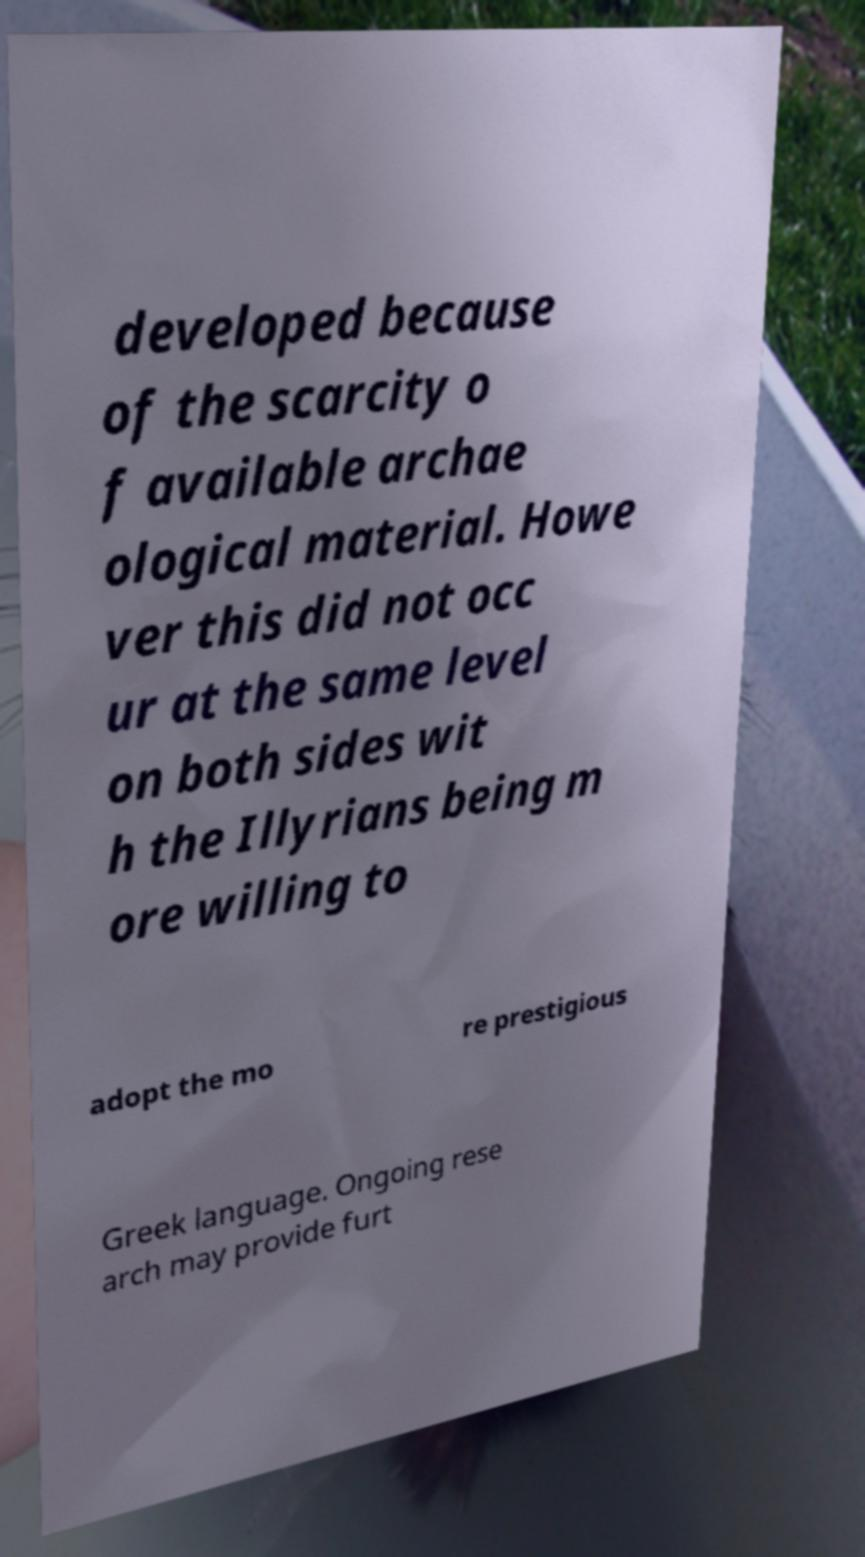Please read and relay the text visible in this image. What does it say? developed because of the scarcity o f available archae ological material. Howe ver this did not occ ur at the same level on both sides wit h the Illyrians being m ore willing to adopt the mo re prestigious Greek language. Ongoing rese arch may provide furt 